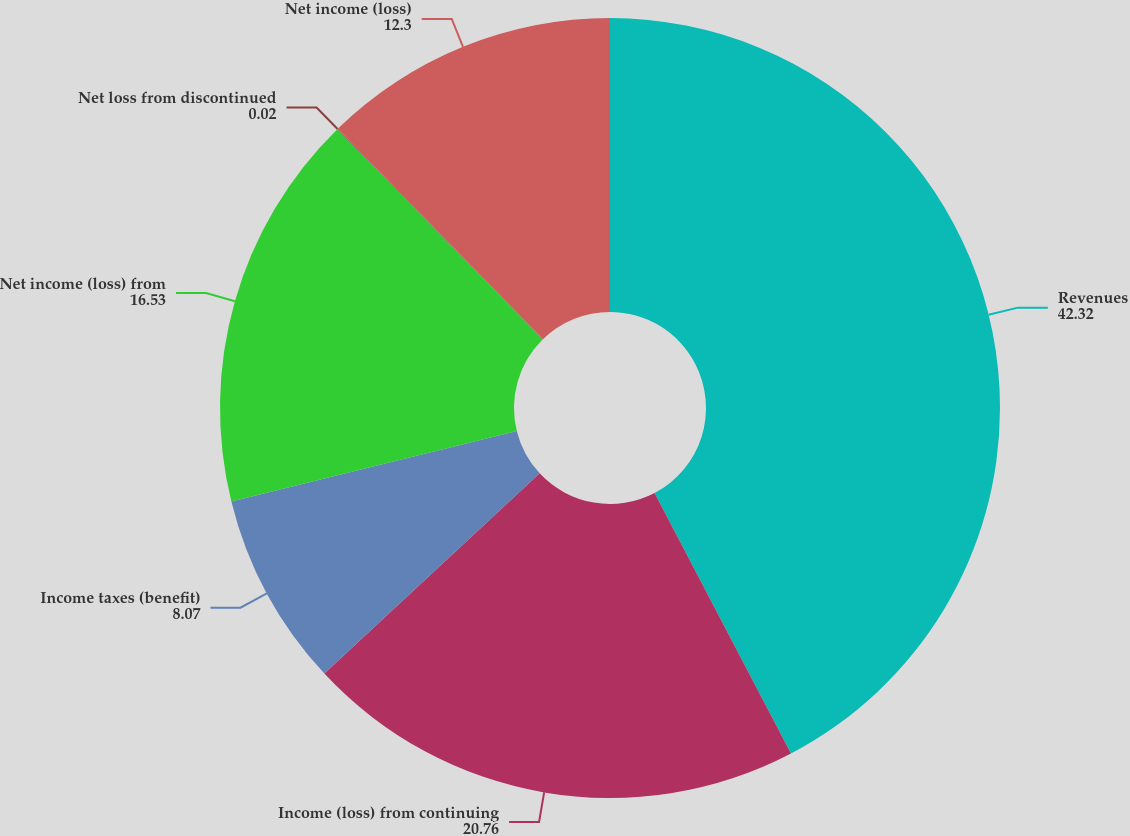<chart> <loc_0><loc_0><loc_500><loc_500><pie_chart><fcel>Revenues<fcel>Income (loss) from continuing<fcel>Income taxes (benefit)<fcel>Net income (loss) from<fcel>Net loss from discontinued<fcel>Net income (loss)<nl><fcel>42.32%<fcel>20.76%<fcel>8.07%<fcel>16.53%<fcel>0.02%<fcel>12.3%<nl></chart> 